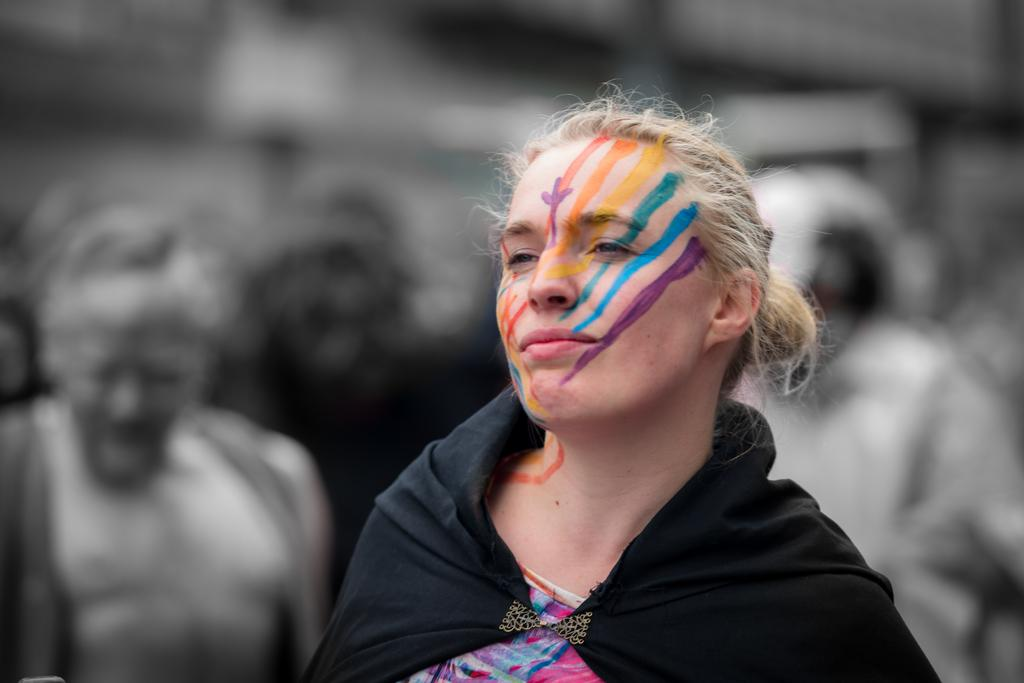Who is present in the image? There is a woman in the image. What is the woman wearing? The woman is wearing black clothing. What can be seen on the woman's face? There are colors on the woman's face. Who else is in the image? There is another person on the left side of the image. How is the other person depicted? The other person is in a black and white image. What type of stone is the woman holding in the image? There is no stone present in the image; the woman is not holding anything. What kind of waste is visible in the image? There is no waste visible in the image; it only features the woman and another person. 